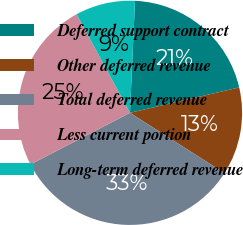Convert chart. <chart><loc_0><loc_0><loc_500><loc_500><pie_chart><fcel>Deferred support contract<fcel>Other deferred revenue<fcel>Total deferred revenue<fcel>Less current portion<fcel>Long-term deferred revenue<nl><fcel>20.65%<fcel>12.68%<fcel>33.33%<fcel>24.71%<fcel>8.62%<nl></chart> 